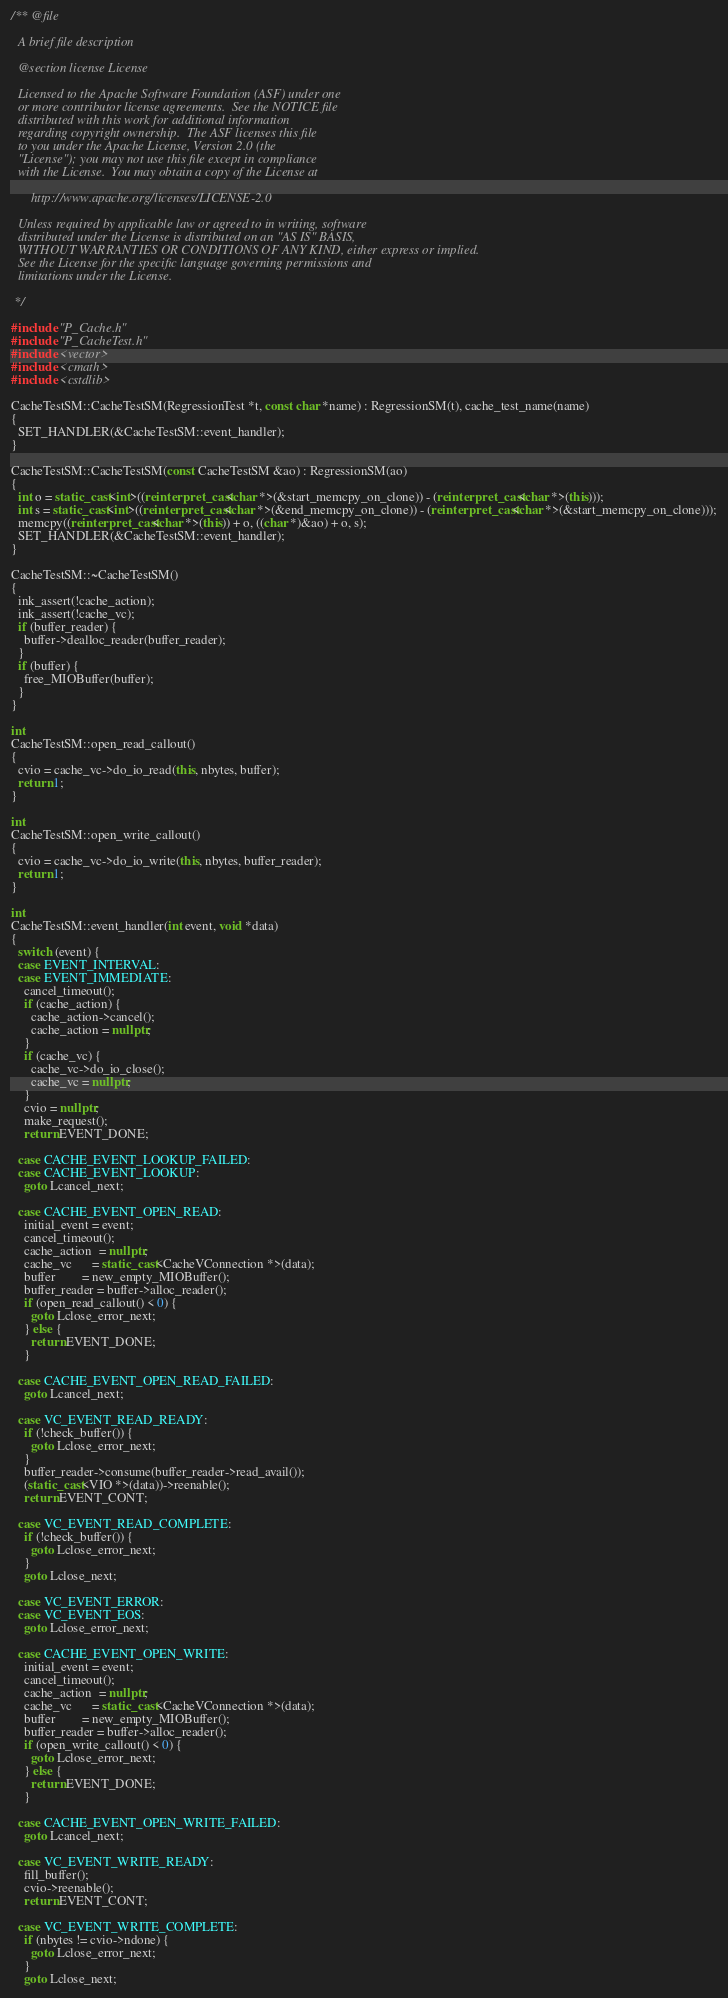Convert code to text. <code><loc_0><loc_0><loc_500><loc_500><_C++_>/** @file

  A brief file description

  @section license License

  Licensed to the Apache Software Foundation (ASF) under one
  or more contributor license agreements.  See the NOTICE file
  distributed with this work for additional information
  regarding copyright ownership.  The ASF licenses this file
  to you under the Apache License, Version 2.0 (the
  "License"); you may not use this file except in compliance
  with the License.  You may obtain a copy of the License at

      http://www.apache.org/licenses/LICENSE-2.0

  Unless required by applicable law or agreed to in writing, software
  distributed under the License is distributed on an "AS IS" BASIS,
  WITHOUT WARRANTIES OR CONDITIONS OF ANY KIND, either express or implied.
  See the License for the specific language governing permissions and
  limitations under the License.

 */

#include "P_Cache.h"
#include "P_CacheTest.h"
#include <vector>
#include <cmath>
#include <cstdlib>

CacheTestSM::CacheTestSM(RegressionTest *t, const char *name) : RegressionSM(t), cache_test_name(name)
{
  SET_HANDLER(&CacheTestSM::event_handler);
}

CacheTestSM::CacheTestSM(const CacheTestSM &ao) : RegressionSM(ao)
{
  int o = static_cast<int>((reinterpret_cast<char *>(&start_memcpy_on_clone)) - (reinterpret_cast<char *>(this)));
  int s = static_cast<int>((reinterpret_cast<char *>(&end_memcpy_on_clone)) - (reinterpret_cast<char *>(&start_memcpy_on_clone)));
  memcpy((reinterpret_cast<char *>(this)) + o, ((char *)&ao) + o, s);
  SET_HANDLER(&CacheTestSM::event_handler);
}

CacheTestSM::~CacheTestSM()
{
  ink_assert(!cache_action);
  ink_assert(!cache_vc);
  if (buffer_reader) {
    buffer->dealloc_reader(buffer_reader);
  }
  if (buffer) {
    free_MIOBuffer(buffer);
  }
}

int
CacheTestSM::open_read_callout()
{
  cvio = cache_vc->do_io_read(this, nbytes, buffer);
  return 1;
}

int
CacheTestSM::open_write_callout()
{
  cvio = cache_vc->do_io_write(this, nbytes, buffer_reader);
  return 1;
}

int
CacheTestSM::event_handler(int event, void *data)
{
  switch (event) {
  case EVENT_INTERVAL:
  case EVENT_IMMEDIATE:
    cancel_timeout();
    if (cache_action) {
      cache_action->cancel();
      cache_action = nullptr;
    }
    if (cache_vc) {
      cache_vc->do_io_close();
      cache_vc = nullptr;
    }
    cvio = nullptr;
    make_request();
    return EVENT_DONE;

  case CACHE_EVENT_LOOKUP_FAILED:
  case CACHE_EVENT_LOOKUP:
    goto Lcancel_next;

  case CACHE_EVENT_OPEN_READ:
    initial_event = event;
    cancel_timeout();
    cache_action  = nullptr;
    cache_vc      = static_cast<CacheVConnection *>(data);
    buffer        = new_empty_MIOBuffer();
    buffer_reader = buffer->alloc_reader();
    if (open_read_callout() < 0) {
      goto Lclose_error_next;
    } else {
      return EVENT_DONE;
    }

  case CACHE_EVENT_OPEN_READ_FAILED:
    goto Lcancel_next;

  case VC_EVENT_READ_READY:
    if (!check_buffer()) {
      goto Lclose_error_next;
    }
    buffer_reader->consume(buffer_reader->read_avail());
    (static_cast<VIO *>(data))->reenable();
    return EVENT_CONT;

  case VC_EVENT_READ_COMPLETE:
    if (!check_buffer()) {
      goto Lclose_error_next;
    }
    goto Lclose_next;

  case VC_EVENT_ERROR:
  case VC_EVENT_EOS:
    goto Lclose_error_next;

  case CACHE_EVENT_OPEN_WRITE:
    initial_event = event;
    cancel_timeout();
    cache_action  = nullptr;
    cache_vc      = static_cast<CacheVConnection *>(data);
    buffer        = new_empty_MIOBuffer();
    buffer_reader = buffer->alloc_reader();
    if (open_write_callout() < 0) {
      goto Lclose_error_next;
    } else {
      return EVENT_DONE;
    }

  case CACHE_EVENT_OPEN_WRITE_FAILED:
    goto Lcancel_next;

  case VC_EVENT_WRITE_READY:
    fill_buffer();
    cvio->reenable();
    return EVENT_CONT;

  case VC_EVENT_WRITE_COMPLETE:
    if (nbytes != cvio->ndone) {
      goto Lclose_error_next;
    }
    goto Lclose_next;
</code> 